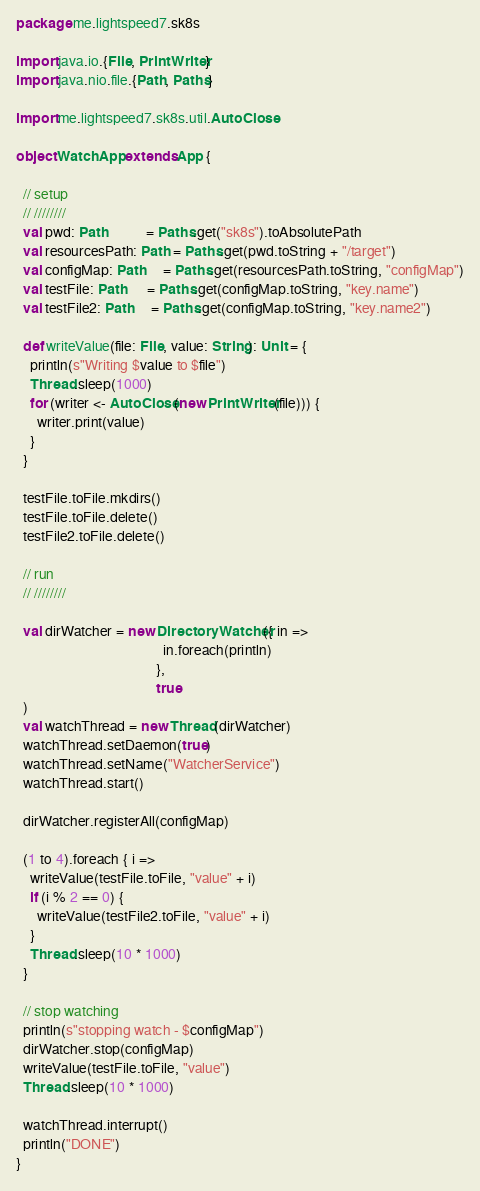<code> <loc_0><loc_0><loc_500><loc_500><_Scala_>package me.lightspeed7.sk8s

import java.io.{File, PrintWriter}
import java.nio.file.{Path, Paths}

import me.lightspeed7.sk8s.util.AutoClose

object WatchApp extends App {

  // setup
  // ////////
  val pwd: Path           = Paths.get("sk8s").toAbsolutePath
  val resourcesPath: Path = Paths.get(pwd.toString + "/target")
  val configMap: Path     = Paths.get(resourcesPath.toString, "configMap")
  val testFile: Path      = Paths.get(configMap.toString, "key.name")
  val testFile2: Path     = Paths.get(configMap.toString, "key.name2")

  def writeValue(file: File, value: String): Unit = {
    println(s"Writing $value to $file")
    Thread.sleep(1000)
    for (writer <- AutoClose(new PrintWriter(file))) {
      writer.print(value)
    }
  }

  testFile.toFile.mkdirs()
  testFile.toFile.delete()
  testFile2.toFile.delete()

  // run
  // ////////

  val dirWatcher = new DirectoryWatcher({ in =>
                                          in.foreach(println)
                                        },
                                        true
  )
  val watchThread = new Thread(dirWatcher)
  watchThread.setDaemon(true)
  watchThread.setName("WatcherService")
  watchThread.start()

  dirWatcher.registerAll(configMap)

  (1 to 4).foreach { i =>
    writeValue(testFile.toFile, "value" + i)
    if (i % 2 == 0) {
      writeValue(testFile2.toFile, "value" + i)
    }
    Thread.sleep(10 * 1000)
  }

  // stop watching
  println(s"stopping watch - $configMap")
  dirWatcher.stop(configMap)
  writeValue(testFile.toFile, "value")
  Thread.sleep(10 * 1000)

  watchThread.interrupt()
  println("DONE")
}
</code> 